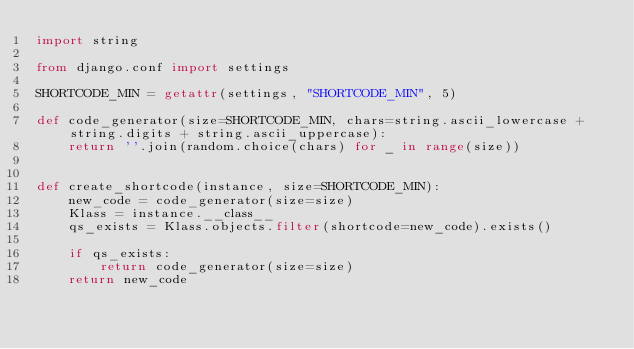Convert code to text. <code><loc_0><loc_0><loc_500><loc_500><_Python_>import string

from django.conf import settings

SHORTCODE_MIN = getattr(settings, "SHORTCODE_MIN", 5)

def code_generator(size=SHORTCODE_MIN, chars=string.ascii_lowercase + string.digits + string.ascii_uppercase):
	return ''.join(random.choice(chars) for _ in range(size))


def create_shortcode(instance, size=SHORTCODE_MIN):
	new_code = code_generator(size=size)
	Klass = instance.__class__
	qs_exists = Klass.objects.filter(shortcode=new_code).exists()
	
	if qs_exists:
		return code_generator(size=size)
	return new_code</code> 